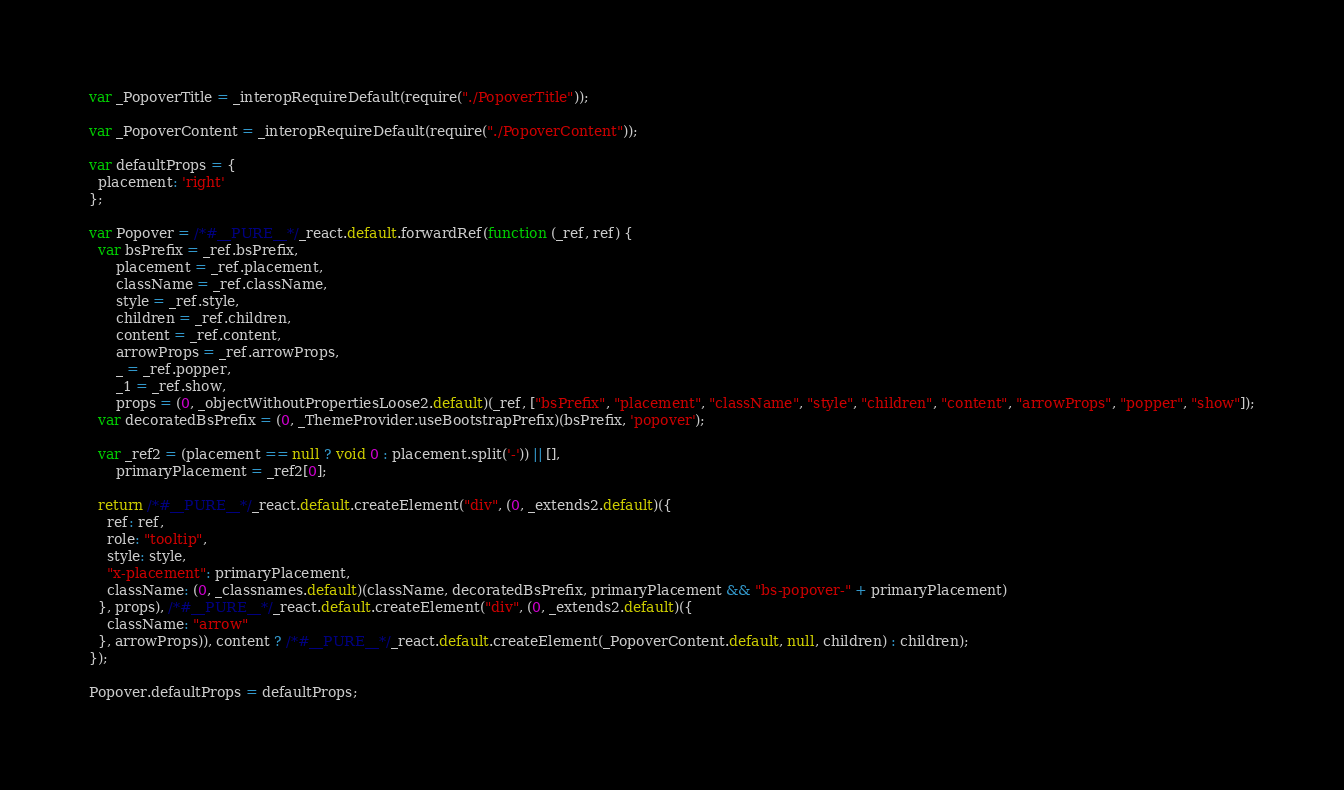<code> <loc_0><loc_0><loc_500><loc_500><_JavaScript_>var _PopoverTitle = _interopRequireDefault(require("./PopoverTitle"));

var _PopoverContent = _interopRequireDefault(require("./PopoverContent"));

var defaultProps = {
  placement: 'right'
};

var Popover = /*#__PURE__*/_react.default.forwardRef(function (_ref, ref) {
  var bsPrefix = _ref.bsPrefix,
      placement = _ref.placement,
      className = _ref.className,
      style = _ref.style,
      children = _ref.children,
      content = _ref.content,
      arrowProps = _ref.arrowProps,
      _ = _ref.popper,
      _1 = _ref.show,
      props = (0, _objectWithoutPropertiesLoose2.default)(_ref, ["bsPrefix", "placement", "className", "style", "children", "content", "arrowProps", "popper", "show"]);
  var decoratedBsPrefix = (0, _ThemeProvider.useBootstrapPrefix)(bsPrefix, 'popover');

  var _ref2 = (placement == null ? void 0 : placement.split('-')) || [],
      primaryPlacement = _ref2[0];

  return /*#__PURE__*/_react.default.createElement("div", (0, _extends2.default)({
    ref: ref,
    role: "tooltip",
    style: style,
    "x-placement": primaryPlacement,
    className: (0, _classnames.default)(className, decoratedBsPrefix, primaryPlacement && "bs-popover-" + primaryPlacement)
  }, props), /*#__PURE__*/_react.default.createElement("div", (0, _extends2.default)({
    className: "arrow"
  }, arrowProps)), content ? /*#__PURE__*/_react.default.createElement(_PopoverContent.default, null, children) : children);
});

Popover.defaultProps = defaultProps;</code> 